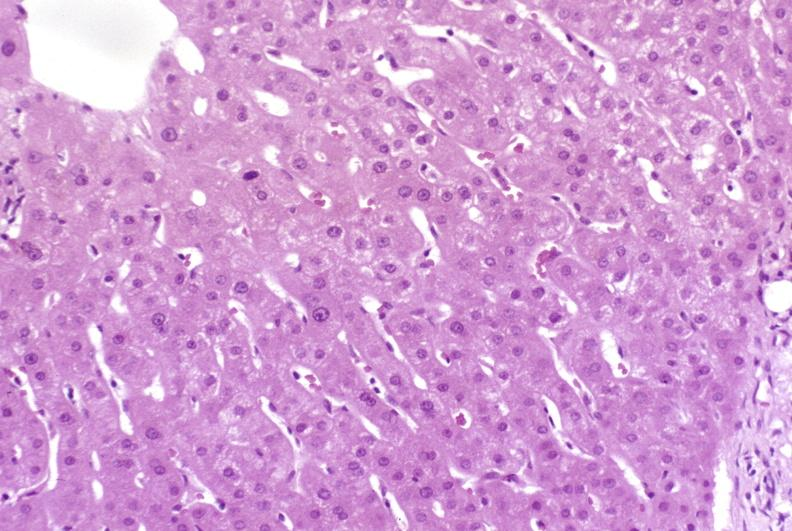what is present?
Answer the question using a single word or phrase. Hepatobiliary 